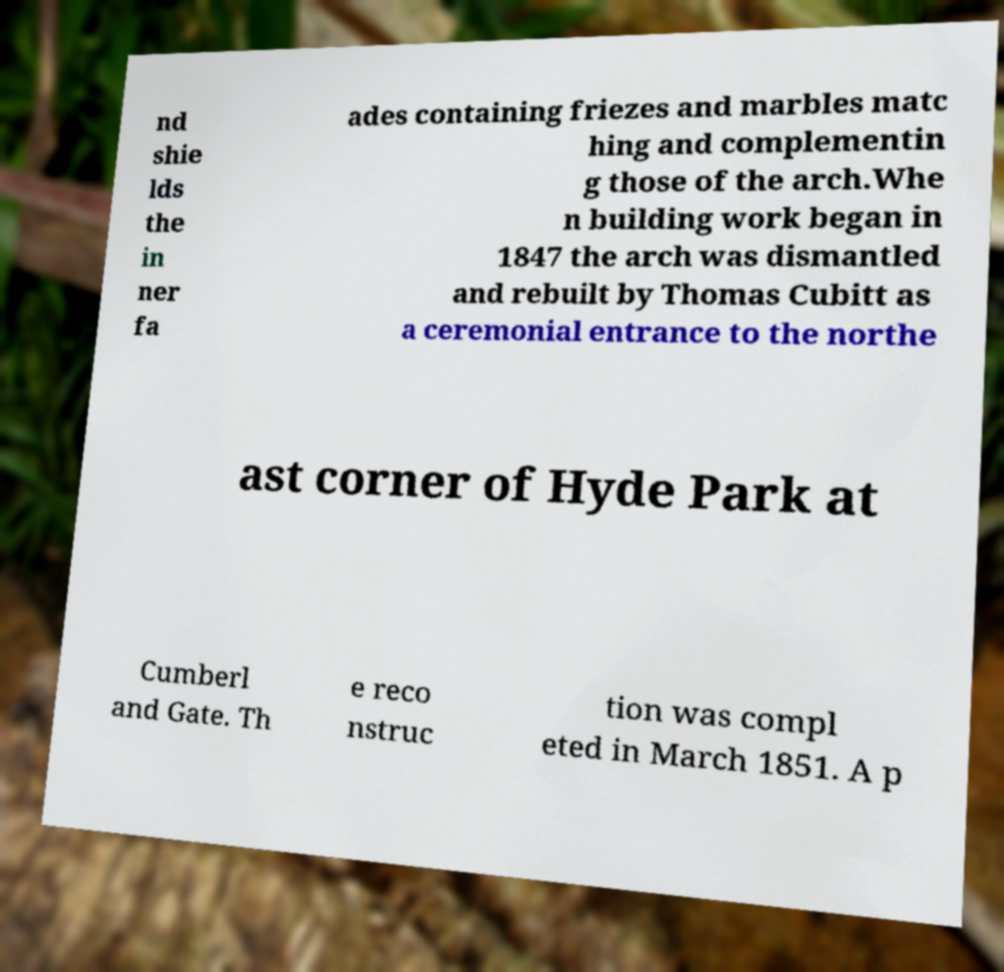Please read and relay the text visible in this image. What does it say? nd shie lds the in ner fa ades containing friezes and marbles matc hing and complementin g those of the arch.Whe n building work began in 1847 the arch was dismantled and rebuilt by Thomas Cubitt as a ceremonial entrance to the northe ast corner of Hyde Park at Cumberl and Gate. Th e reco nstruc tion was compl eted in March 1851. A p 